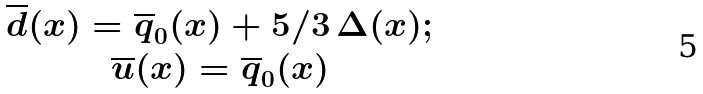<formula> <loc_0><loc_0><loc_500><loc_500>\begin{array} { c l c r } \overline { d } ( x ) = \overline { q } _ { 0 } ( x ) + 5 / 3 \, \Delta ( x ) ; \\ \overline { u } ( x ) = \overline { q } _ { 0 } ( x ) \end{array}</formula> 